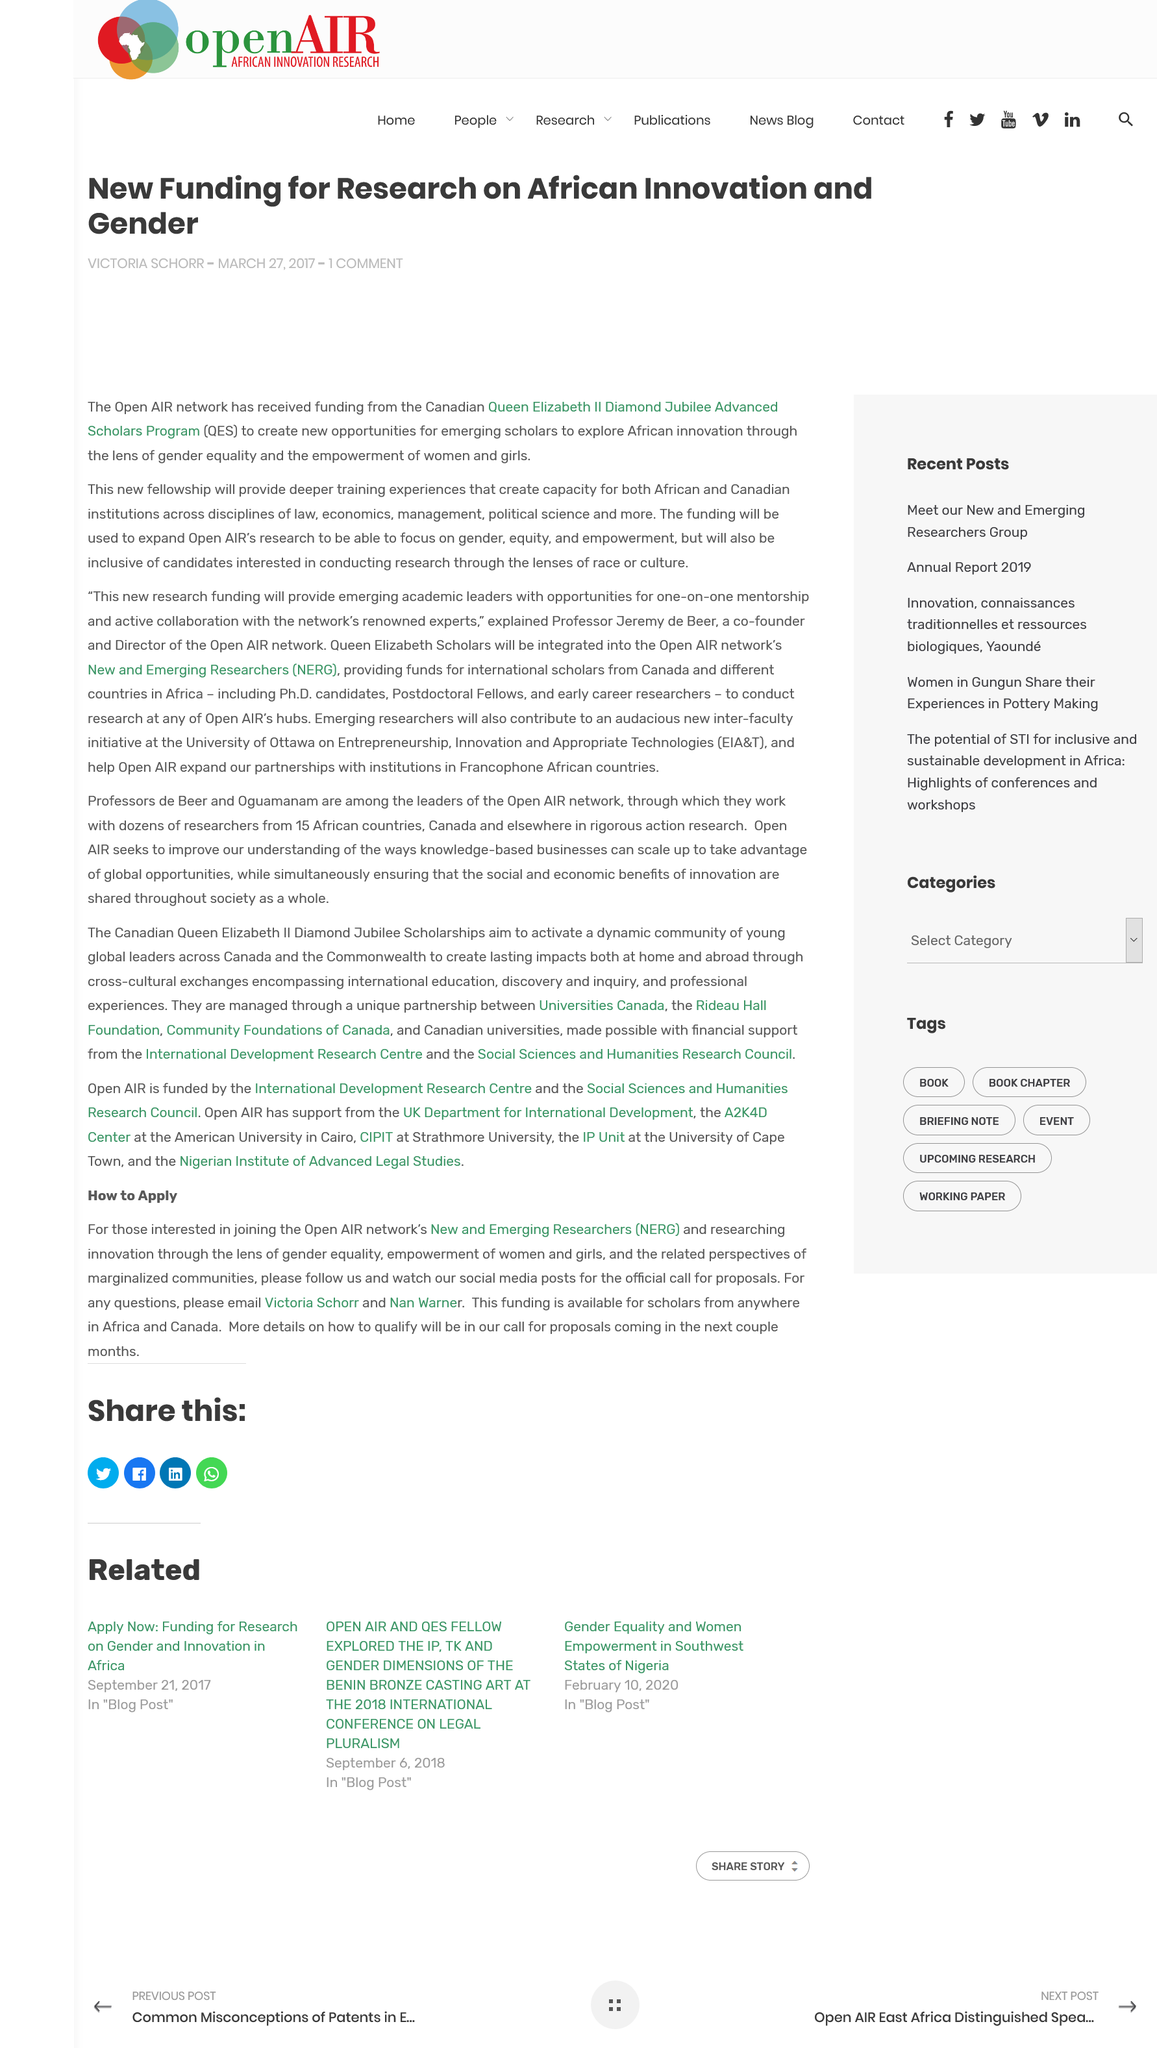Point out several critical features in this image. In the article, "New and Emerging Researchers: A Guide to Mobilizing Energy and Resources," NERG stands for "New and Emerging Researchers Group," which is a collective of researchers who are dedicated to advancing their careers and making meaningful contributions to their respective fields. Africa and Canada are home to scholars from various countries who are available for funding opportunities. It is recommended that any queries be directed to Victoria Schorr and Nan Warner. 